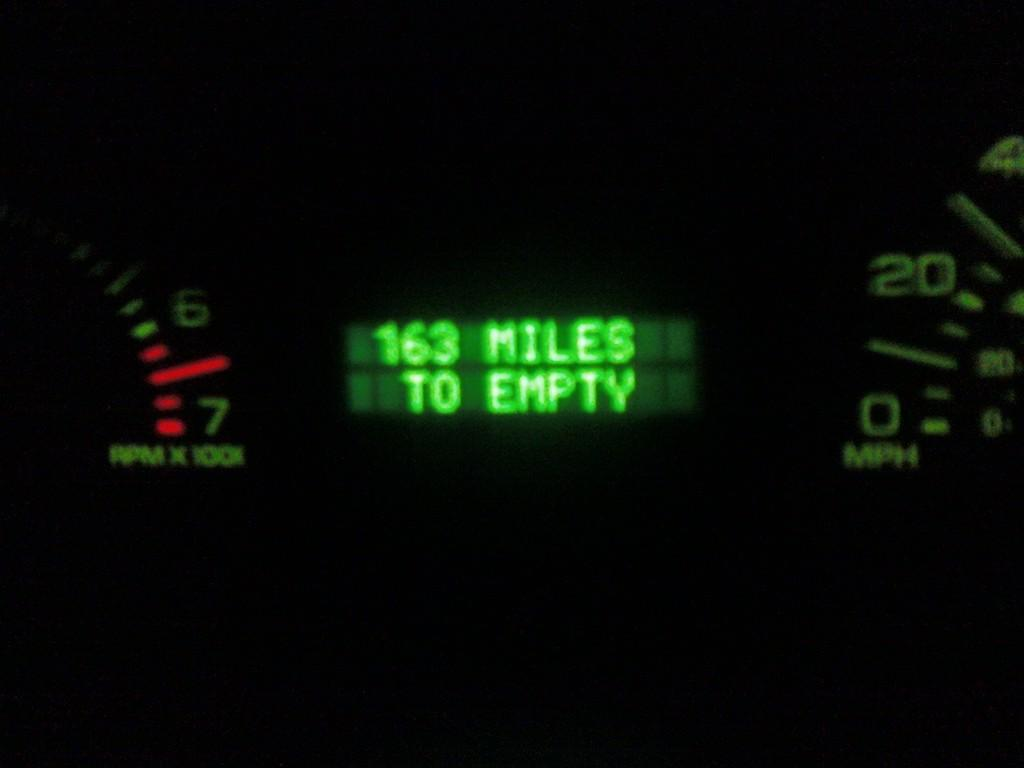What type of instrument is present in the image? There is a speedometer in the image. Can you see any yaks in the image? There are no yaks present in the image. What type of harbor is visible in the image? There is no harbor present in the image; it only features a speedometer. 